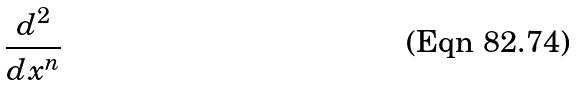<formula> <loc_0><loc_0><loc_500><loc_500>\frac { d ^ { 2 } } { d x ^ { n } }</formula> 